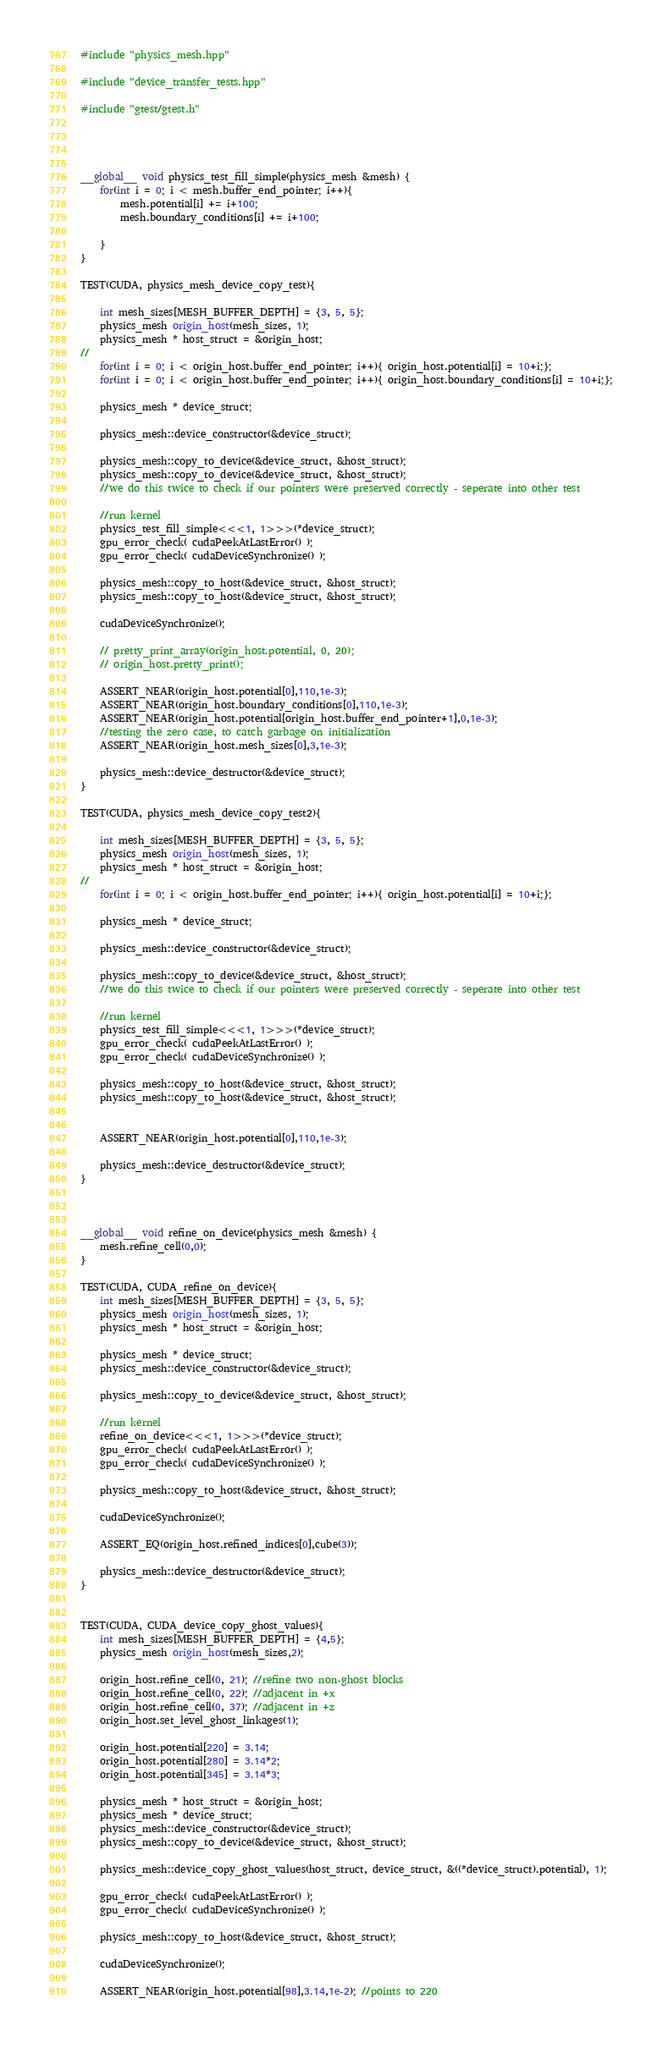<code> <loc_0><loc_0><loc_500><loc_500><_Cuda_>#include "physics_mesh.hpp"

#include "device_transfer_tests.hpp"

#include "gtest/gtest.h"




__global__ void physics_test_fill_simple(physics_mesh &mesh) {
    for(int i = 0; i < mesh.buffer_end_pointer; i++){
        mesh.potential[i] += i+100;
        mesh.boundary_conditions[i] += i+100;

    }
}

TEST(CUDA, physics_mesh_device_copy_test){

    int mesh_sizes[MESH_BUFFER_DEPTH] = {3, 5, 5};
    physics_mesh origin_host(mesh_sizes, 1);
    physics_mesh * host_struct = &origin_host;
//
    for(int i = 0; i < origin_host.buffer_end_pointer; i++){ origin_host.potential[i] = 10+i;};
    for(int i = 0; i < origin_host.buffer_end_pointer; i++){ origin_host.boundary_conditions[i] = 10+i;};

    physics_mesh * device_struct;

    physics_mesh::device_constructor(&device_struct);

    physics_mesh::copy_to_device(&device_struct, &host_struct);
    physics_mesh::copy_to_device(&device_struct, &host_struct);
    //we do this twice to check if our pointers were preserved correctly - seperate into other test

    //run kernel
    physics_test_fill_simple<<<1, 1>>>(*device_struct);
    gpu_error_check( cudaPeekAtLastError() );
    gpu_error_check( cudaDeviceSynchronize() );

    physics_mesh::copy_to_host(&device_struct, &host_struct);
    physics_mesh::copy_to_host(&device_struct, &host_struct);

    cudaDeviceSynchronize();

    // pretty_print_array(origin_host.potential, 0, 20);
    // origin_host.pretty_print();

    ASSERT_NEAR(origin_host.potential[0],110,1e-3);
    ASSERT_NEAR(origin_host.boundary_conditions[0],110,1e-3);
    ASSERT_NEAR(origin_host.potential[origin_host.buffer_end_pointer+1],0,1e-3);
    //testing the zero case, to catch garbage on initialization
    ASSERT_NEAR(origin_host.mesh_sizes[0],3,1e-3);

    physics_mesh::device_destructor(&device_struct);
}

TEST(CUDA, physics_mesh_device_copy_test2){

    int mesh_sizes[MESH_BUFFER_DEPTH] = {3, 5, 5};
    physics_mesh origin_host(mesh_sizes, 1);
    physics_mesh * host_struct = &origin_host;
//
    for(int i = 0; i < origin_host.buffer_end_pointer; i++){ origin_host.potential[i] = 10+i;};

    physics_mesh * device_struct;

    physics_mesh::device_constructor(&device_struct);

    physics_mesh::copy_to_device(&device_struct, &host_struct);
    //we do this twice to check if our pointers were preserved correctly - seperate into other test

    //run kernel
    physics_test_fill_simple<<<1, 1>>>(*device_struct);
    gpu_error_check( cudaPeekAtLastError() );
    gpu_error_check( cudaDeviceSynchronize() );

    physics_mesh::copy_to_host(&device_struct, &host_struct);
    physics_mesh::copy_to_host(&device_struct, &host_struct);


    ASSERT_NEAR(origin_host.potential[0],110,1e-3);

    physics_mesh::device_destructor(&device_struct);
}



__global__ void refine_on_device(physics_mesh &mesh) {
    mesh.refine_cell(0,0);
}

TEST(CUDA, CUDA_refine_on_device){
    int mesh_sizes[MESH_BUFFER_DEPTH] = {3, 5, 5};
    physics_mesh origin_host(mesh_sizes, 1);
    physics_mesh * host_struct = &origin_host;

    physics_mesh * device_struct;
    physics_mesh::device_constructor(&device_struct);

    physics_mesh::copy_to_device(&device_struct, &host_struct);

    //run kernel
    refine_on_device<<<1, 1>>>(*device_struct);
    gpu_error_check( cudaPeekAtLastError() );
    gpu_error_check( cudaDeviceSynchronize() );

    physics_mesh::copy_to_host(&device_struct, &host_struct);

    cudaDeviceSynchronize();

    ASSERT_EQ(origin_host.refined_indices[0],cube(3));

    physics_mesh::device_destructor(&device_struct);
}


TEST(CUDA, CUDA_device_copy_ghost_values){
    int mesh_sizes[MESH_BUFFER_DEPTH] = {4,5};
    physics_mesh origin_host(mesh_sizes,2);

    origin_host.refine_cell(0, 21); //refine two non-ghost blocks
    origin_host.refine_cell(0, 22); //adjacent in +x
    origin_host.refine_cell(0, 37); //adjacent in +z
    origin_host.set_level_ghost_linkages(1);

    origin_host.potential[220] = 3.14;
    origin_host.potential[280] = 3.14*2;
    origin_host.potential[345] = 3.14*3;

    physics_mesh * host_struct = &origin_host;
    physics_mesh * device_struct;
    physics_mesh::device_constructor(&device_struct);
    physics_mesh::copy_to_device(&device_struct, &host_struct);

    physics_mesh::device_copy_ghost_values(host_struct, device_struct, &((*device_struct).potential), 1);

    gpu_error_check( cudaPeekAtLastError() );
    gpu_error_check( cudaDeviceSynchronize() );

    physics_mesh::copy_to_host(&device_struct, &host_struct);

    cudaDeviceSynchronize();

    ASSERT_NEAR(origin_host.potential[98],3.14,1e-2); //points to 220</code> 